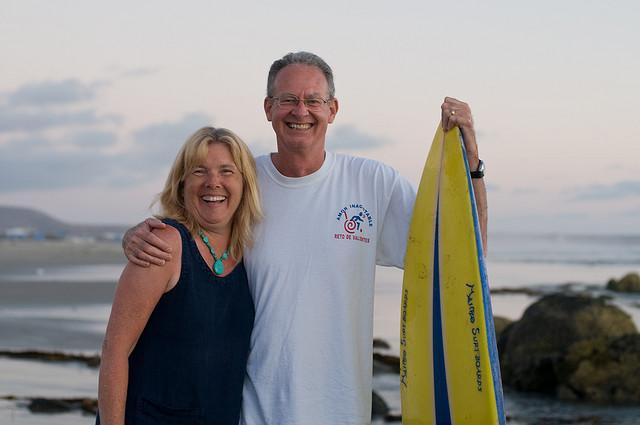Which person is holding the most weight from the surfboard?
Be succinct. Man. What color is the sky?
Short answer required. Gray. Is the surfboard bigger than the man?
Be succinct. No. What color is the photo?
Quick response, please. White. What is on the man's face?
Write a very short answer. Glasses. On which body part is his hand resting?
Give a very brief answer. Shoulder. Is the man on a surfboard?
Write a very short answer. No. Is the surfer's head visible in this photo?
Short answer required. Yes. Will she go surfing now?
Answer briefly. No. How many girls are there?
Quick response, please. 1. Is the guy wearing sunglasses?
Answer briefly. No. Is the man married?
Write a very short answer. Yes. What color is the surfboard?
Write a very short answer. Yellow and blue. How many surfboards are in this picture?
Concise answer only. 1. What is the woman doing?
Write a very short answer. Smiling. What is the lady holding?
Short answer required. Man. Does this view have an animated quality to it?
Quick response, please. No. What is the man holding?
Write a very short answer. Surfboard. 